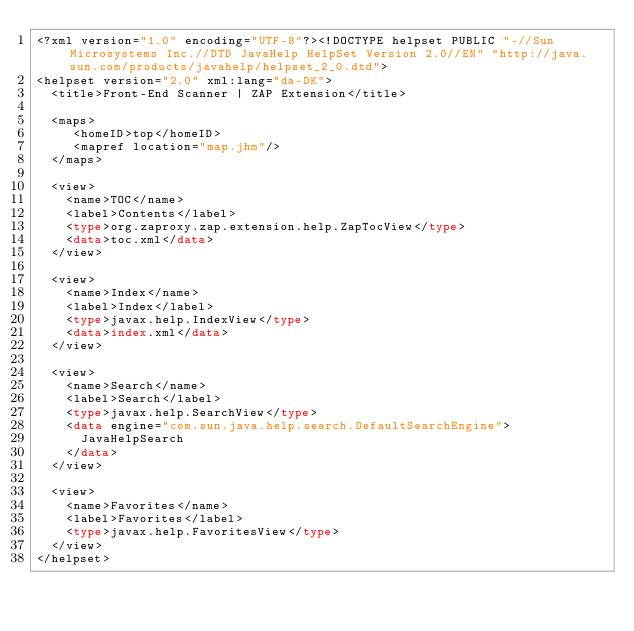<code> <loc_0><loc_0><loc_500><loc_500><_Haskell_><?xml version="1.0" encoding="UTF-8"?><!DOCTYPE helpset PUBLIC "-//Sun Microsystems Inc.//DTD JavaHelp HelpSet Version 2.0//EN" "http://java.sun.com/products/javahelp/helpset_2_0.dtd">
<helpset version="2.0" xml:lang="da-DK">
  <title>Front-End Scanner | ZAP Extension</title>

  <maps>
     <homeID>top</homeID>
     <mapref location="map.jhm"/>
  </maps>

  <view>
    <name>TOC</name>
    <label>Contents</label>
    <type>org.zaproxy.zap.extension.help.ZapTocView</type>
    <data>toc.xml</data>
  </view>

  <view>
    <name>Index</name>
    <label>Index</label>
    <type>javax.help.IndexView</type>
    <data>index.xml</data>
  </view>

  <view>
    <name>Search</name>
    <label>Search</label>
    <type>javax.help.SearchView</type>
    <data engine="com.sun.java.help.search.DefaultSearchEngine">
      JavaHelpSearch
    </data>
  </view>

  <view>
    <name>Favorites</name>
    <label>Favorites</label>
    <type>javax.help.FavoritesView</type>
  </view>
</helpset></code> 